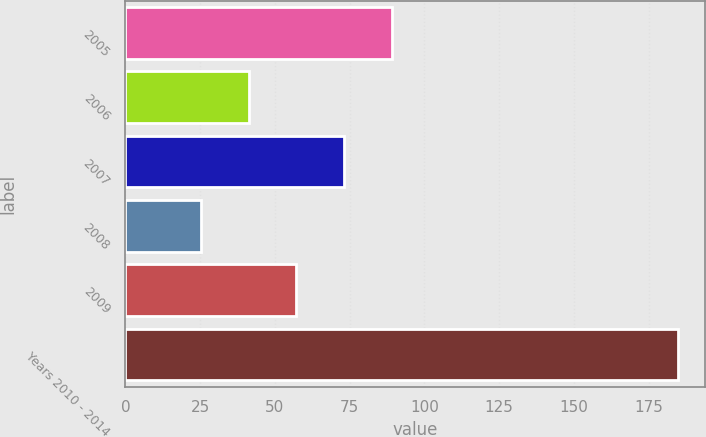<chart> <loc_0><loc_0><loc_500><loc_500><bar_chart><fcel>2005<fcel>2006<fcel>2007<fcel>2008<fcel>2009<fcel>Years 2010 - 2014<nl><fcel>89.06<fcel>41.24<fcel>73.12<fcel>25.3<fcel>57.18<fcel>184.7<nl></chart> 